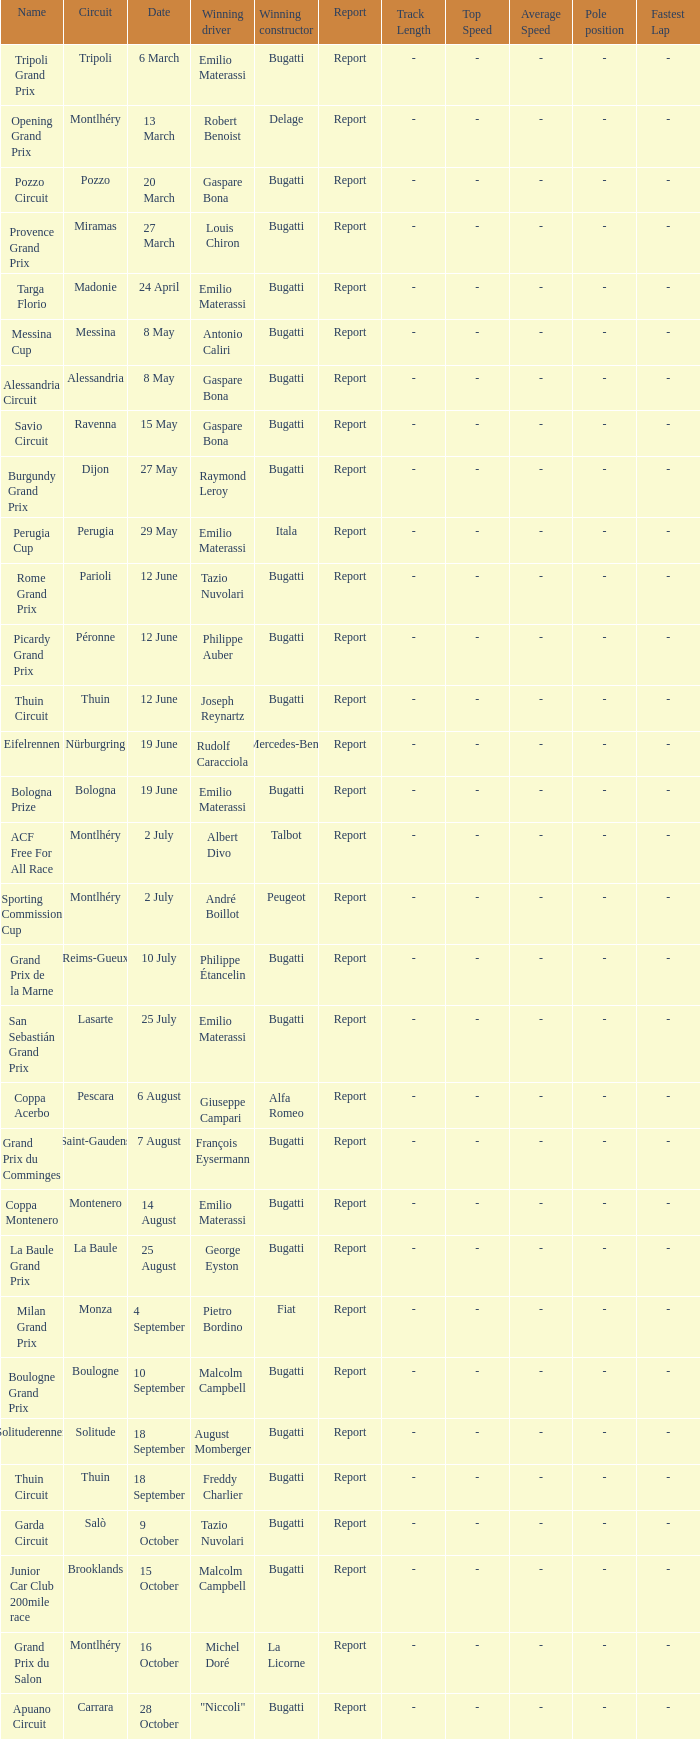Who was the winning constructor at the circuit of parioli? Bugatti. 